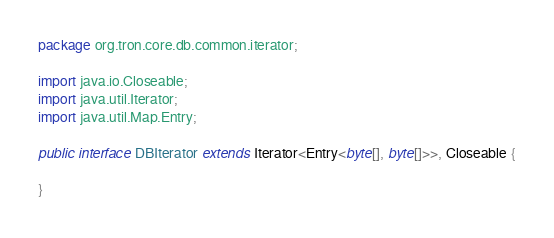Convert code to text. <code><loc_0><loc_0><loc_500><loc_500><_Java_>package org.tron.core.db.common.iterator;

import java.io.Closeable;
import java.util.Iterator;
import java.util.Map.Entry;

public interface DBIterator extends Iterator<Entry<byte[], byte[]>>, Closeable {

}
</code> 